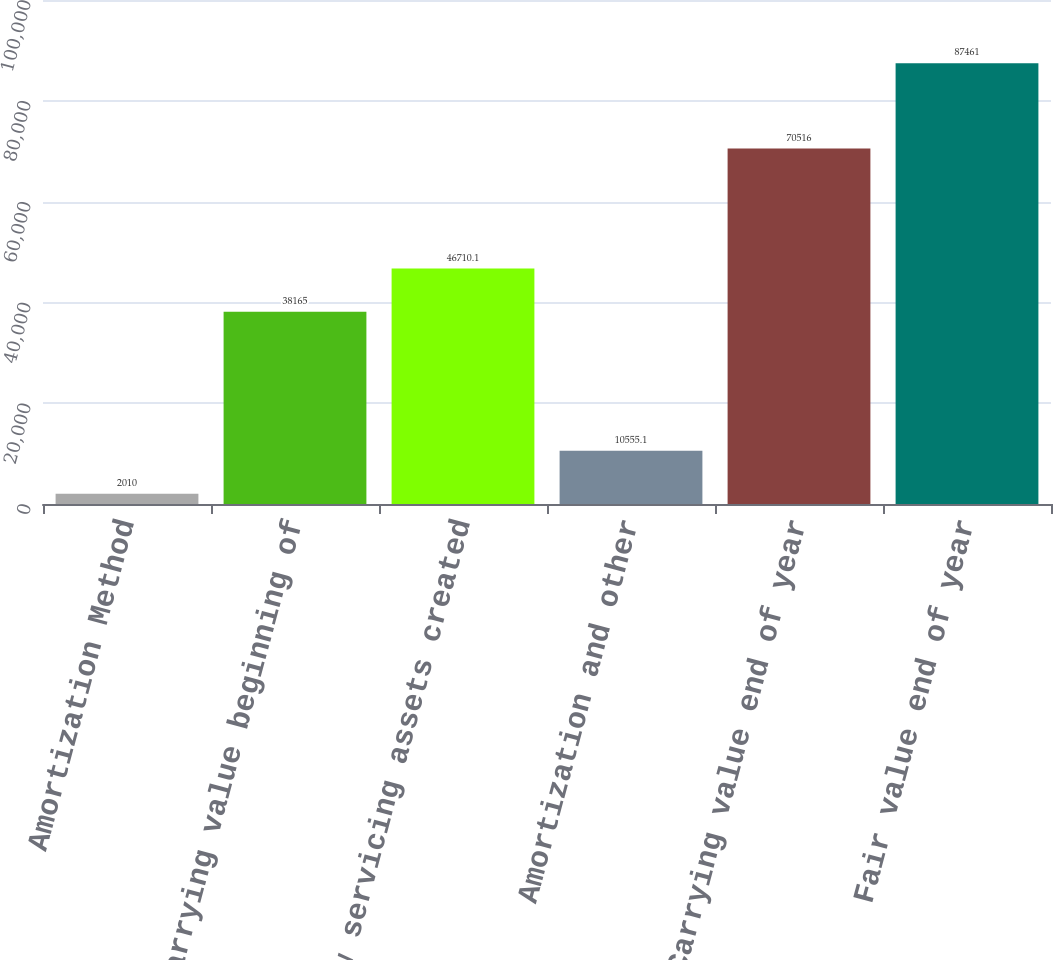Convert chart. <chart><loc_0><loc_0><loc_500><loc_500><bar_chart><fcel>Amortization Method<fcel>Carrying value beginning of<fcel>New servicing assets created<fcel>Amortization and other<fcel>Carrying value end of year<fcel>Fair value end of year<nl><fcel>2010<fcel>38165<fcel>46710.1<fcel>10555.1<fcel>70516<fcel>87461<nl></chart> 